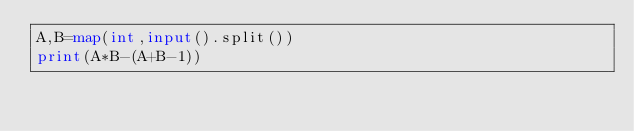<code> <loc_0><loc_0><loc_500><loc_500><_Python_>A,B=map(int,input().split())
print(A*B-(A+B-1))</code> 